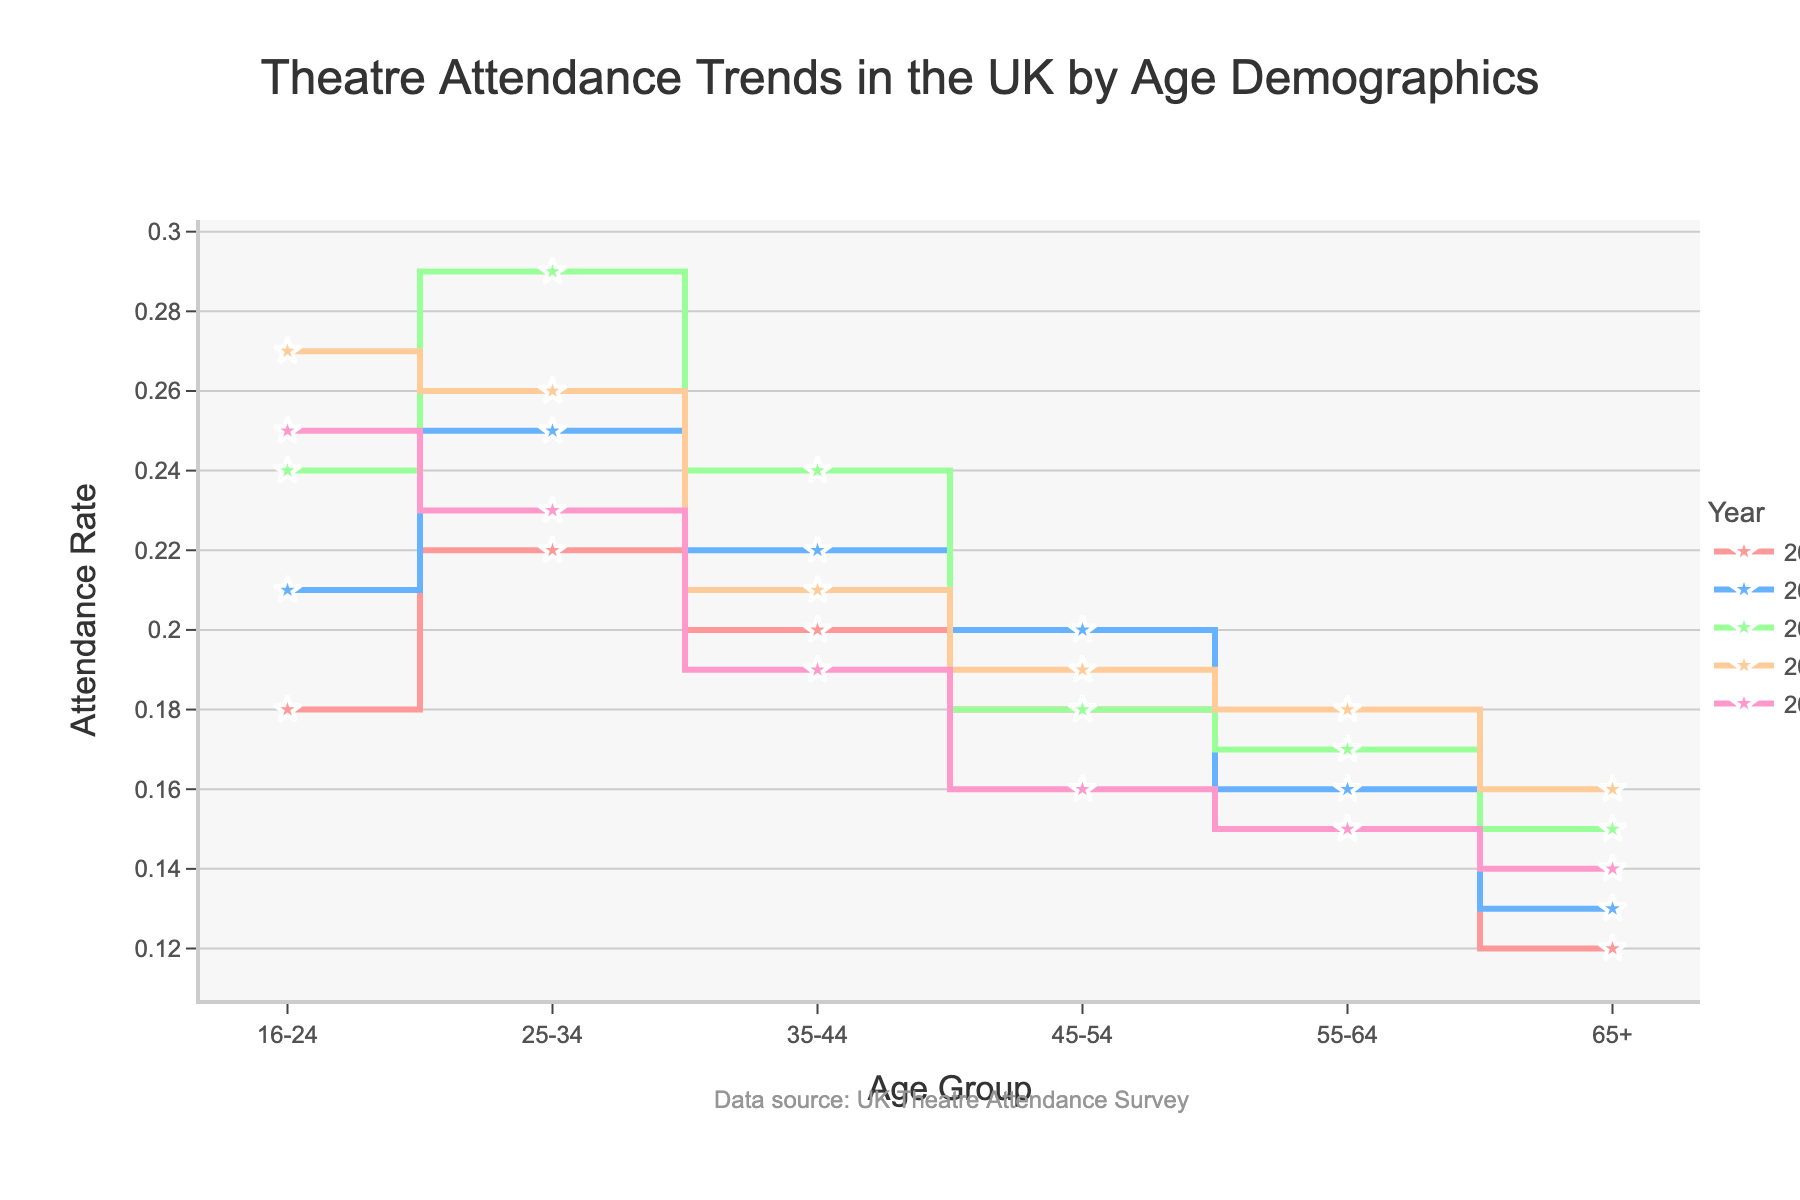What's the title of the plot? The title is clearly mentioned at the top of the plot, indicating what the visualization is about.
Answer: Theatre Attendance Trends in the UK by Age Demographics What are the age groups displayed on the x-axis? The age groups are listed along the x-axis at the bottom of the plot. These are categories into which the data is segmented.
Answer: 16-24, 25-34, 35-44, 45-54, 55-64, 65+ How did the attendance rate for the 16-24 age group change from 2000 to 2020? To answer this, locate the 16-24 age group along the x-axis and observe the y-values for the years 2000 and 2020.
Answer: Increased from 0.18 to 0.25 Which age group had the highest theatre attendance rate in 2010? Look for the data points corresponding to the year 2010 and compare the heights of the different lines to determine which age group had the highest rate.
Answer: 25-34 In which year did the 25-34 age group experience a decrease in attendance rate from the previous recorded year? Follow the trend line for the 25-34 age group and identify any year where the attendance rate drops compared to the previous year.
Answer: 2015 By how much did the attendance rate for the 45-54 age group change from 2000 to 2020? Compare the attendance rate for the 45-54 age group in the years 2000 and 2020, and compute the difference between these rates.
Answer: Decreased by 0.02 Which age group had the smallest change in theatre attendance rate over the 20-year period? Assess the variation in attendance rates from 2000 to 2020 for each age group and identify the one with the smallest difference.
Answer: 55-64 Compare the attendance rates for the 65+ age group between 2000 and 2015. What is the percentage change? First, find the rates for 2000 and 2015 for the 65+ age group. Then, calculate the percentage change using the formula: ((rate in 2015 - rate in 2000) / rate in 2000) * 100.
Answer: 33.33% What general trend in theatre attendance can be observed for the 35-44 age group over the years? Observe the overall direction in which the line representing the 35-44 age group moves from 2000 to 2020.
Answer: Declining Which year showed the highest overall attendance rate among all age groups? Identify which year's lines are generally higher across all age groups, indicating a peak in attendance rates.
Answer: 2010 